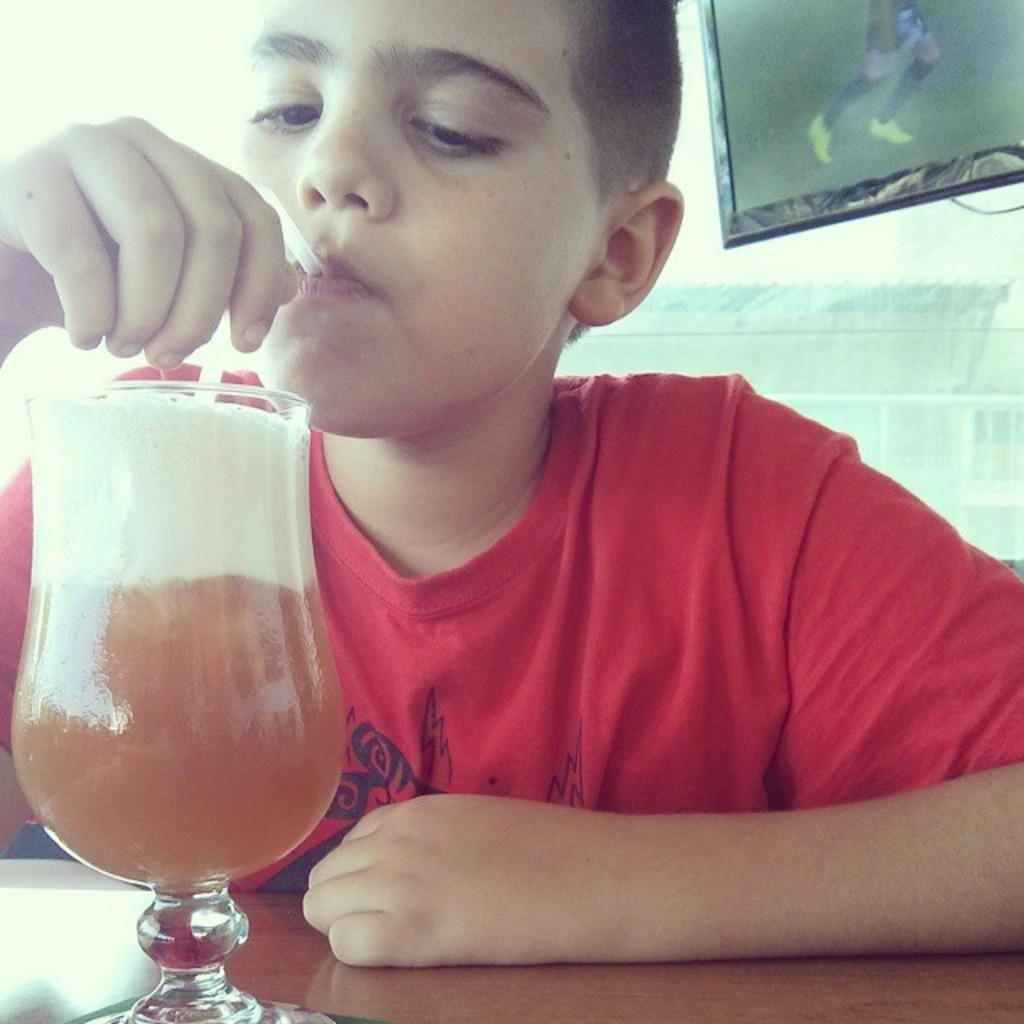Who is the main subject in the image? There is a boy in the image. What is the boy doing in the image? The boy is drinking juice. How is the boy drinking the juice? The boy is using a straw to drink the juice. What is the boy wearing in the image? The boy is wearing a red t-shirt. What can be seen in the background of the image? There is a TV screen in the background of the image. What type of mark can be seen on the boy's forehead in the image? There is no mark visible on the boy's forehead in the image. What kind of branch is the boy holding in the image? There is no branch present in the image; the boy is drinking juice using a straw. 